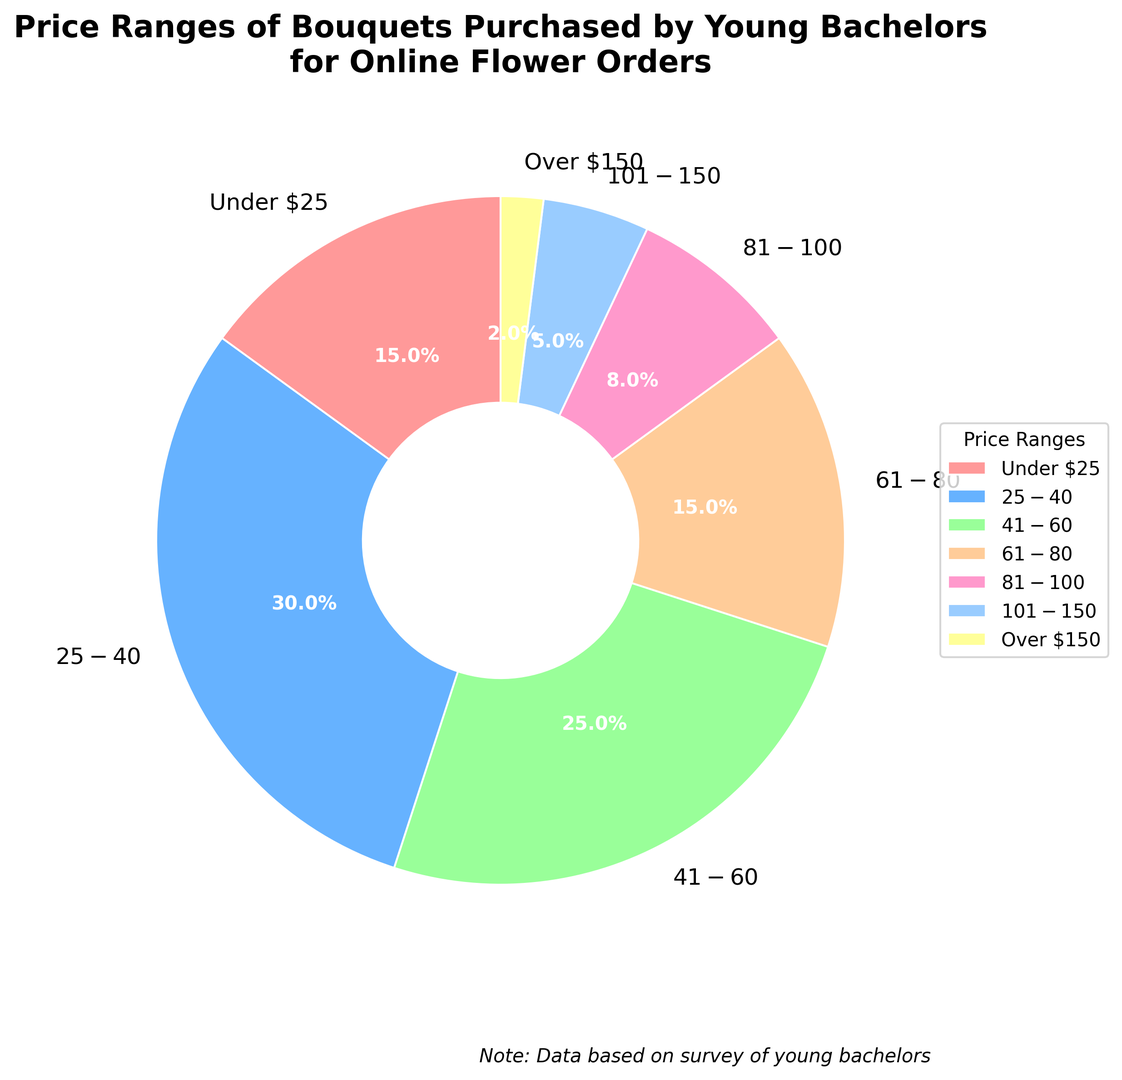Which price range has the highest percentage of bouquets purchased? The pie chart shows that the $25-$40 price range has the largest section. By visually inspecting the chart, one can see that this section occupies the most space.
Answer: $25-$40 Which price range has the lowest percentage of bouquets purchased? By looking at the smallest section of the pie chart, you can see that the "Over $150" section occupies the least space.
Answer: Over $150 What's the combined percentage of bouquets purchased that cost between $25 and $60? To find the combined percentage, add together the percentages for $25-$40 and $41-$60. These are 30% and 25%, respectively. So, 30% + 25% = 55%.
Answer: 55% How much higher in percentage is the $25-$40 range compared to the $41-$60 range? Subtract the percentage for $41-$60 from the percentage for $25-$40. This is 30% - 25% = 5%.
Answer: 5% What is the total percentage of bouquets purchased that cost less than or equal to $40? To find this, add up the percentages of the "Under $25" and "$25-$40" categories. These are 15% and 30%, respectively. So, 15% + 30% = 45%.
Answer: 45% Compare the percentage of bouquets purchased in the $61-$80 range to those in the $81-$100 range. Which has more, and by how much? First, identify the percentages for both ranges: $61-$80 is 15%, and $81-$100 is 8%. Then, subtract the smaller percentage from the larger one: 15% - 8% = 7%. The $61-$80 range has 7% more.
Answer: $61-$80 by 7% What is the combined percentage for bouquets that cost over $100? Add the percentages for $101-$150 and Over $150. These are 5% and 2%, respectively. So, 5% + 2% = 7%.
Answer: 7% Which price ranges have an equal percentage of bouquets purchased? By examining the pie chart, you can see that both "Under $25" and "$61-$80" have the same percentage, which is 15%.
Answer: Under $25 and $61-$80 What is the visual color of the section representing the $25-$40 price range? Look at the color directly associated with the $25-$40 price range in the pie chart. The $25-$40 section is represented in blue.
Answer: Blue 